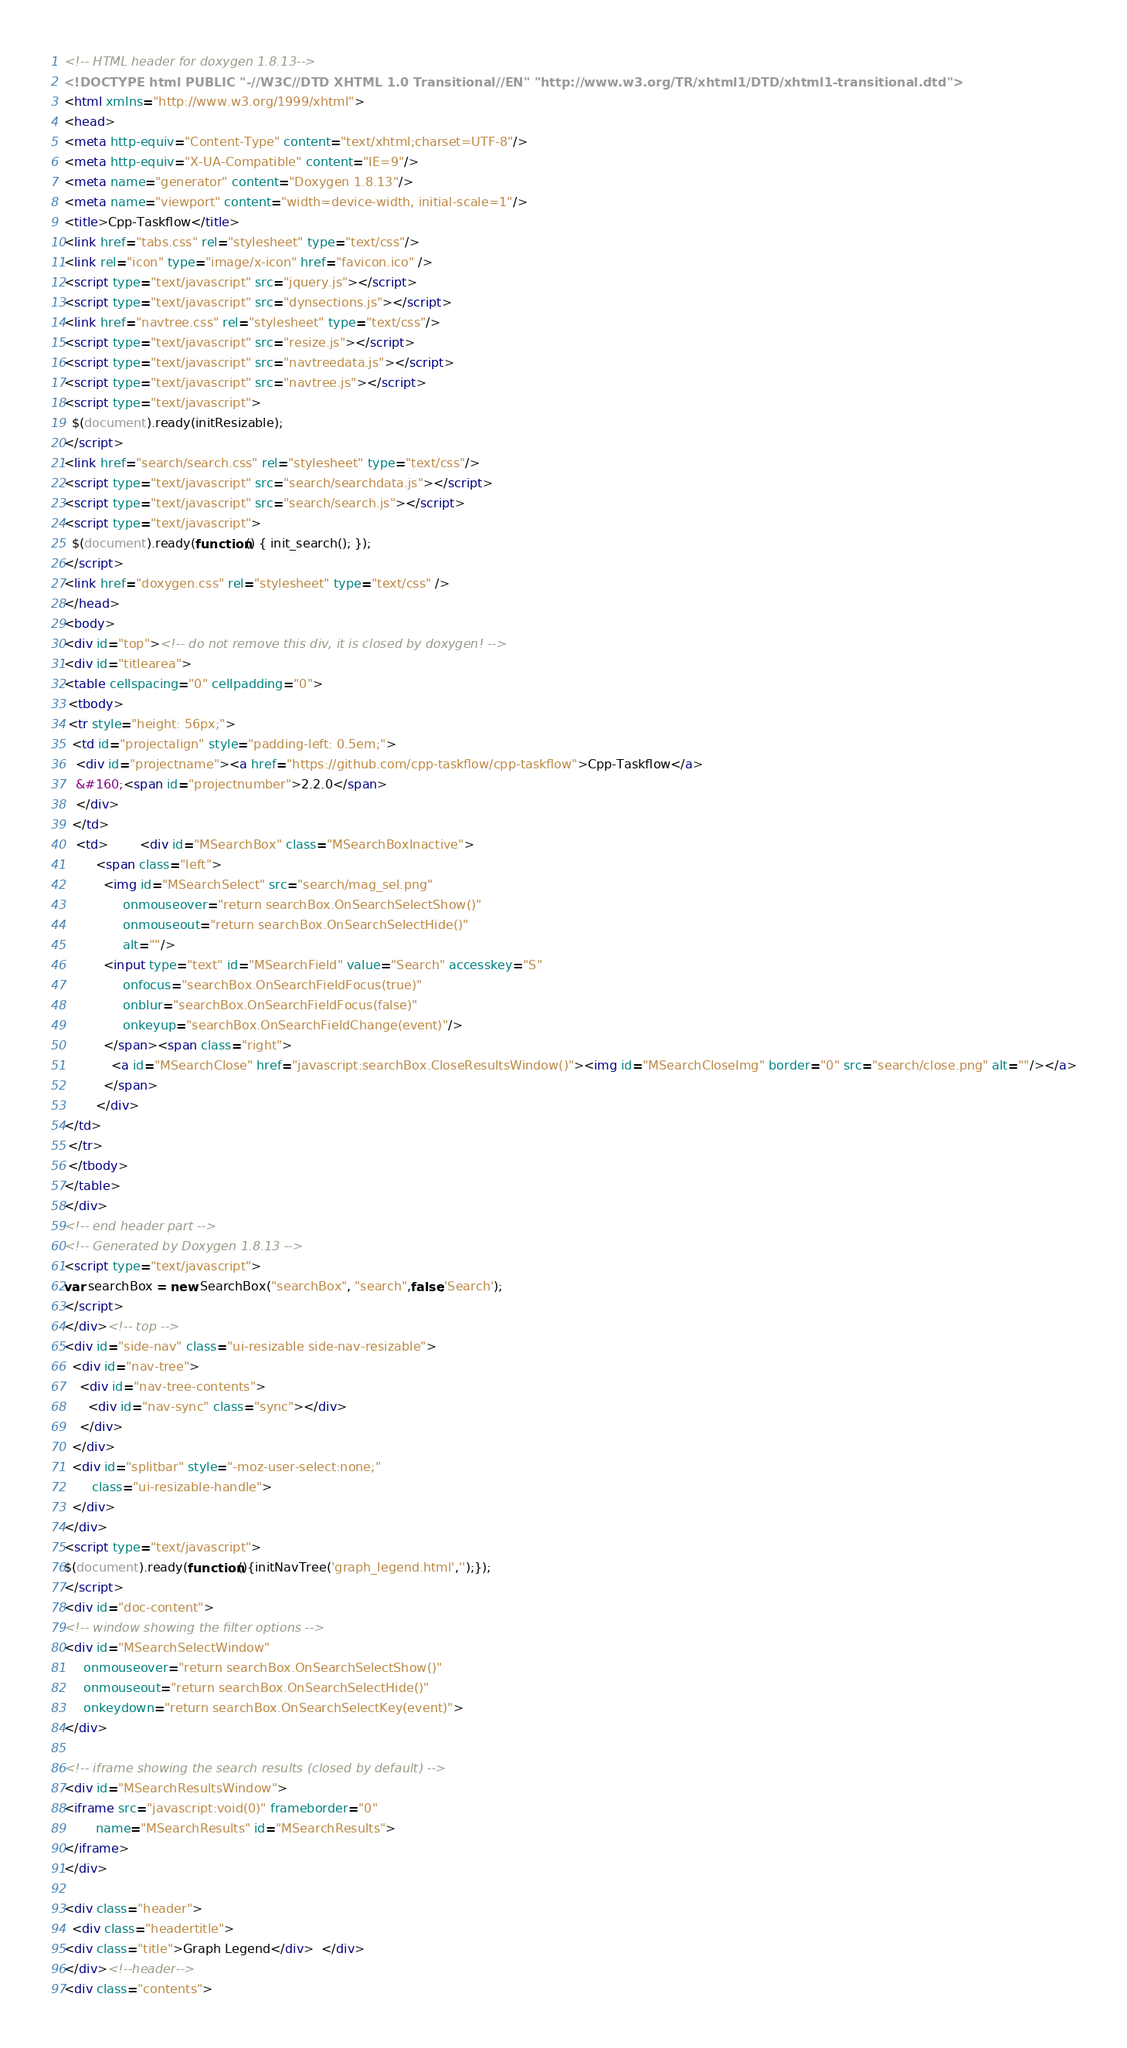<code> <loc_0><loc_0><loc_500><loc_500><_HTML_><!-- HTML header for doxygen 1.8.13-->
<!DOCTYPE html PUBLIC "-//W3C//DTD XHTML 1.0 Transitional//EN" "http://www.w3.org/TR/xhtml1/DTD/xhtml1-transitional.dtd">
<html xmlns="http://www.w3.org/1999/xhtml">
<head>
<meta http-equiv="Content-Type" content="text/xhtml;charset=UTF-8"/>
<meta http-equiv="X-UA-Compatible" content="IE=9"/>
<meta name="generator" content="Doxygen 1.8.13"/>
<meta name="viewport" content="width=device-width, initial-scale=1"/>
<title>Cpp-Taskflow</title>
<link href="tabs.css" rel="stylesheet" type="text/css"/>
<link rel="icon" type="image/x-icon" href="favicon.ico" />
<script type="text/javascript" src="jquery.js"></script>
<script type="text/javascript" src="dynsections.js"></script>
<link href="navtree.css" rel="stylesheet" type="text/css"/>
<script type="text/javascript" src="resize.js"></script>
<script type="text/javascript" src="navtreedata.js"></script>
<script type="text/javascript" src="navtree.js"></script>
<script type="text/javascript">
  $(document).ready(initResizable);
</script>
<link href="search/search.css" rel="stylesheet" type="text/css"/>
<script type="text/javascript" src="search/searchdata.js"></script>
<script type="text/javascript" src="search/search.js"></script>
<script type="text/javascript">
  $(document).ready(function() { init_search(); });
</script>
<link href="doxygen.css" rel="stylesheet" type="text/css" />
</head>
<body>
<div id="top"><!-- do not remove this div, it is closed by doxygen! -->
<div id="titlearea">
<table cellspacing="0" cellpadding="0">
 <tbody>
 <tr style="height: 56px;">
  <td id="projectalign" style="padding-left: 0.5em;">
   <div id="projectname"><a href="https://github.com/cpp-taskflow/cpp-taskflow">Cpp-Taskflow</a>
   &#160;<span id="projectnumber">2.2.0</span>
   </div>
  </td>
   <td>        <div id="MSearchBox" class="MSearchBoxInactive">
        <span class="left">
          <img id="MSearchSelect" src="search/mag_sel.png"
               onmouseover="return searchBox.OnSearchSelectShow()"
               onmouseout="return searchBox.OnSearchSelectHide()"
               alt=""/>
          <input type="text" id="MSearchField" value="Search" accesskey="S"
               onfocus="searchBox.OnSearchFieldFocus(true)" 
               onblur="searchBox.OnSearchFieldFocus(false)" 
               onkeyup="searchBox.OnSearchFieldChange(event)"/>
          </span><span class="right">
            <a id="MSearchClose" href="javascript:searchBox.CloseResultsWindow()"><img id="MSearchCloseImg" border="0" src="search/close.png" alt=""/></a>
          </span>
        </div>
</td>
 </tr>
 </tbody>
</table>
</div>
<!-- end header part -->
<!-- Generated by Doxygen 1.8.13 -->
<script type="text/javascript">
var searchBox = new SearchBox("searchBox", "search",false,'Search');
</script>
</div><!-- top -->
<div id="side-nav" class="ui-resizable side-nav-resizable">
  <div id="nav-tree">
    <div id="nav-tree-contents">
      <div id="nav-sync" class="sync"></div>
    </div>
  </div>
  <div id="splitbar" style="-moz-user-select:none;" 
       class="ui-resizable-handle">
  </div>
</div>
<script type="text/javascript">
$(document).ready(function(){initNavTree('graph_legend.html','');});
</script>
<div id="doc-content">
<!-- window showing the filter options -->
<div id="MSearchSelectWindow"
     onmouseover="return searchBox.OnSearchSelectShow()"
     onmouseout="return searchBox.OnSearchSelectHide()"
     onkeydown="return searchBox.OnSearchSelectKey(event)">
</div>

<!-- iframe showing the search results (closed by default) -->
<div id="MSearchResultsWindow">
<iframe src="javascript:void(0)" frameborder="0" 
        name="MSearchResults" id="MSearchResults">
</iframe>
</div>

<div class="header">
  <div class="headertitle">
<div class="title">Graph Legend</div>  </div>
</div><!--header-->
<div class="contents"></code> 